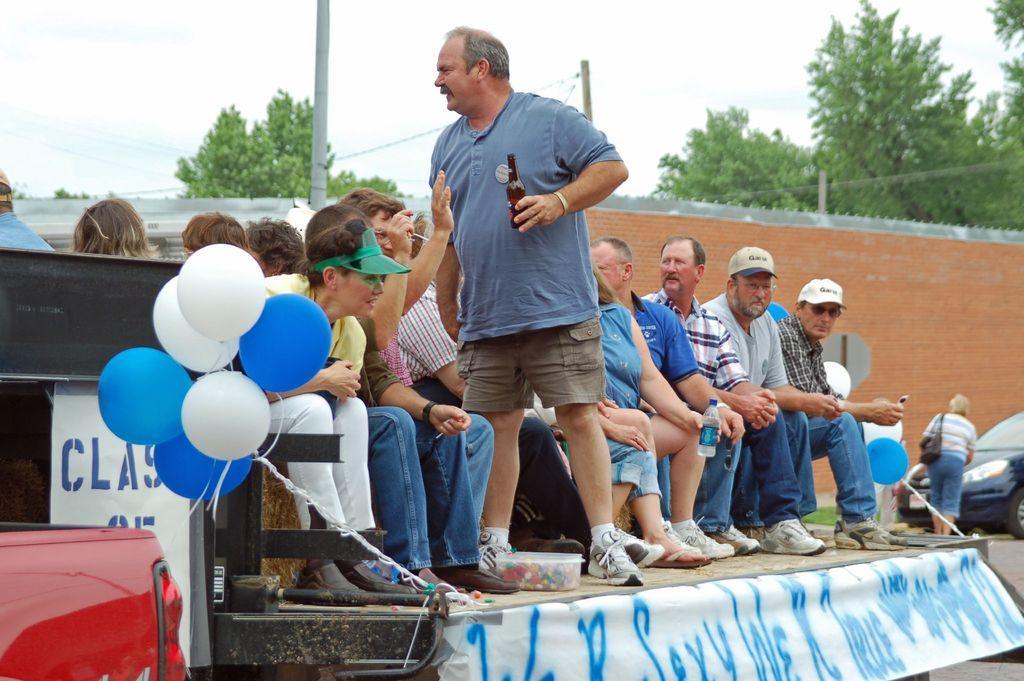In one or two sentences, can you explain what this image depicts? In this image, we can see people and some are wearing caps and holding objects and there are balloons, banners with some text and we can see a vehicle on the road and there is a lady wearing a bag. In the background, there are trees and we can see poles along with wires. 